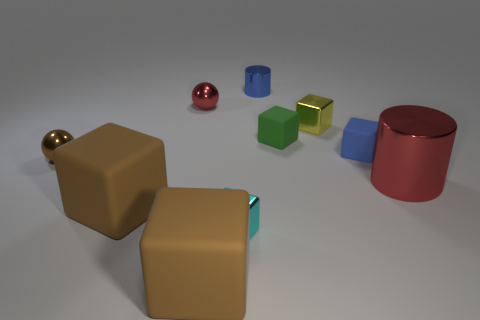Subtract all cyan blocks. How many blocks are left? 5 Subtract all green matte blocks. How many blocks are left? 5 Subtract all red blocks. Subtract all green spheres. How many blocks are left? 6 Subtract all balls. How many objects are left? 8 Subtract all metal cylinders. Subtract all big red metallic things. How many objects are left? 7 Add 2 brown metallic spheres. How many brown metallic spheres are left? 3 Add 2 cylinders. How many cylinders exist? 4 Subtract 0 gray balls. How many objects are left? 10 